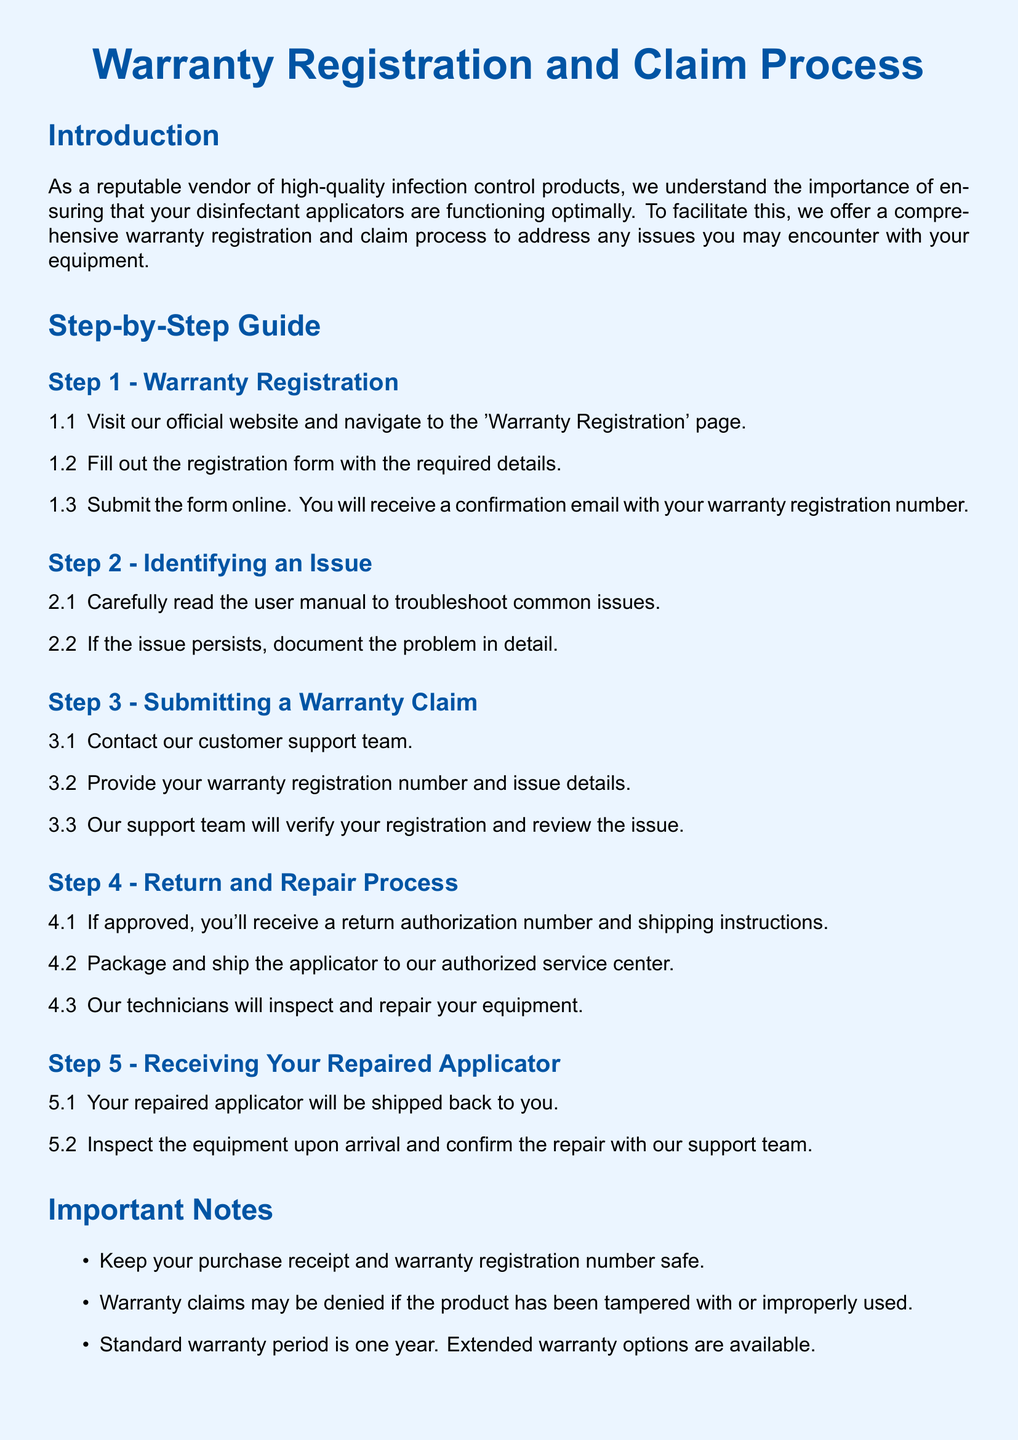What is the warranty period? The warranty period mentioned in the document is one year.
Answer: one year What should you do to register the warranty? To register the warranty, you need to fill out the registration form on the official website.
Answer: fill out the registration form What do you need to contact customer support? You need to provide your warranty registration number and issue details when contacting customer support.
Answer: warranty registration number and issue details What happens if the product is tampered with? If the product has been tampered with, warranty claims may be denied.
Answer: warranty claims may be denied What is the first step in the claim process? The first step in the claim process is to contact customer support.
Answer: contact customer support Where can you find the customer support phone number? The customer support phone number is listed in the contact information section of the document.
Answer: 1-800-555-1234 What will you receive upon warranty registration? Upon warranty registration, you will receive a confirmation email with your warranty registration number.
Answer: confirmation email with your warranty registration number What should you keep safe after registration? You should keep your purchase receipt and warranty registration number safe.
Answer: purchase receipt and warranty registration number 